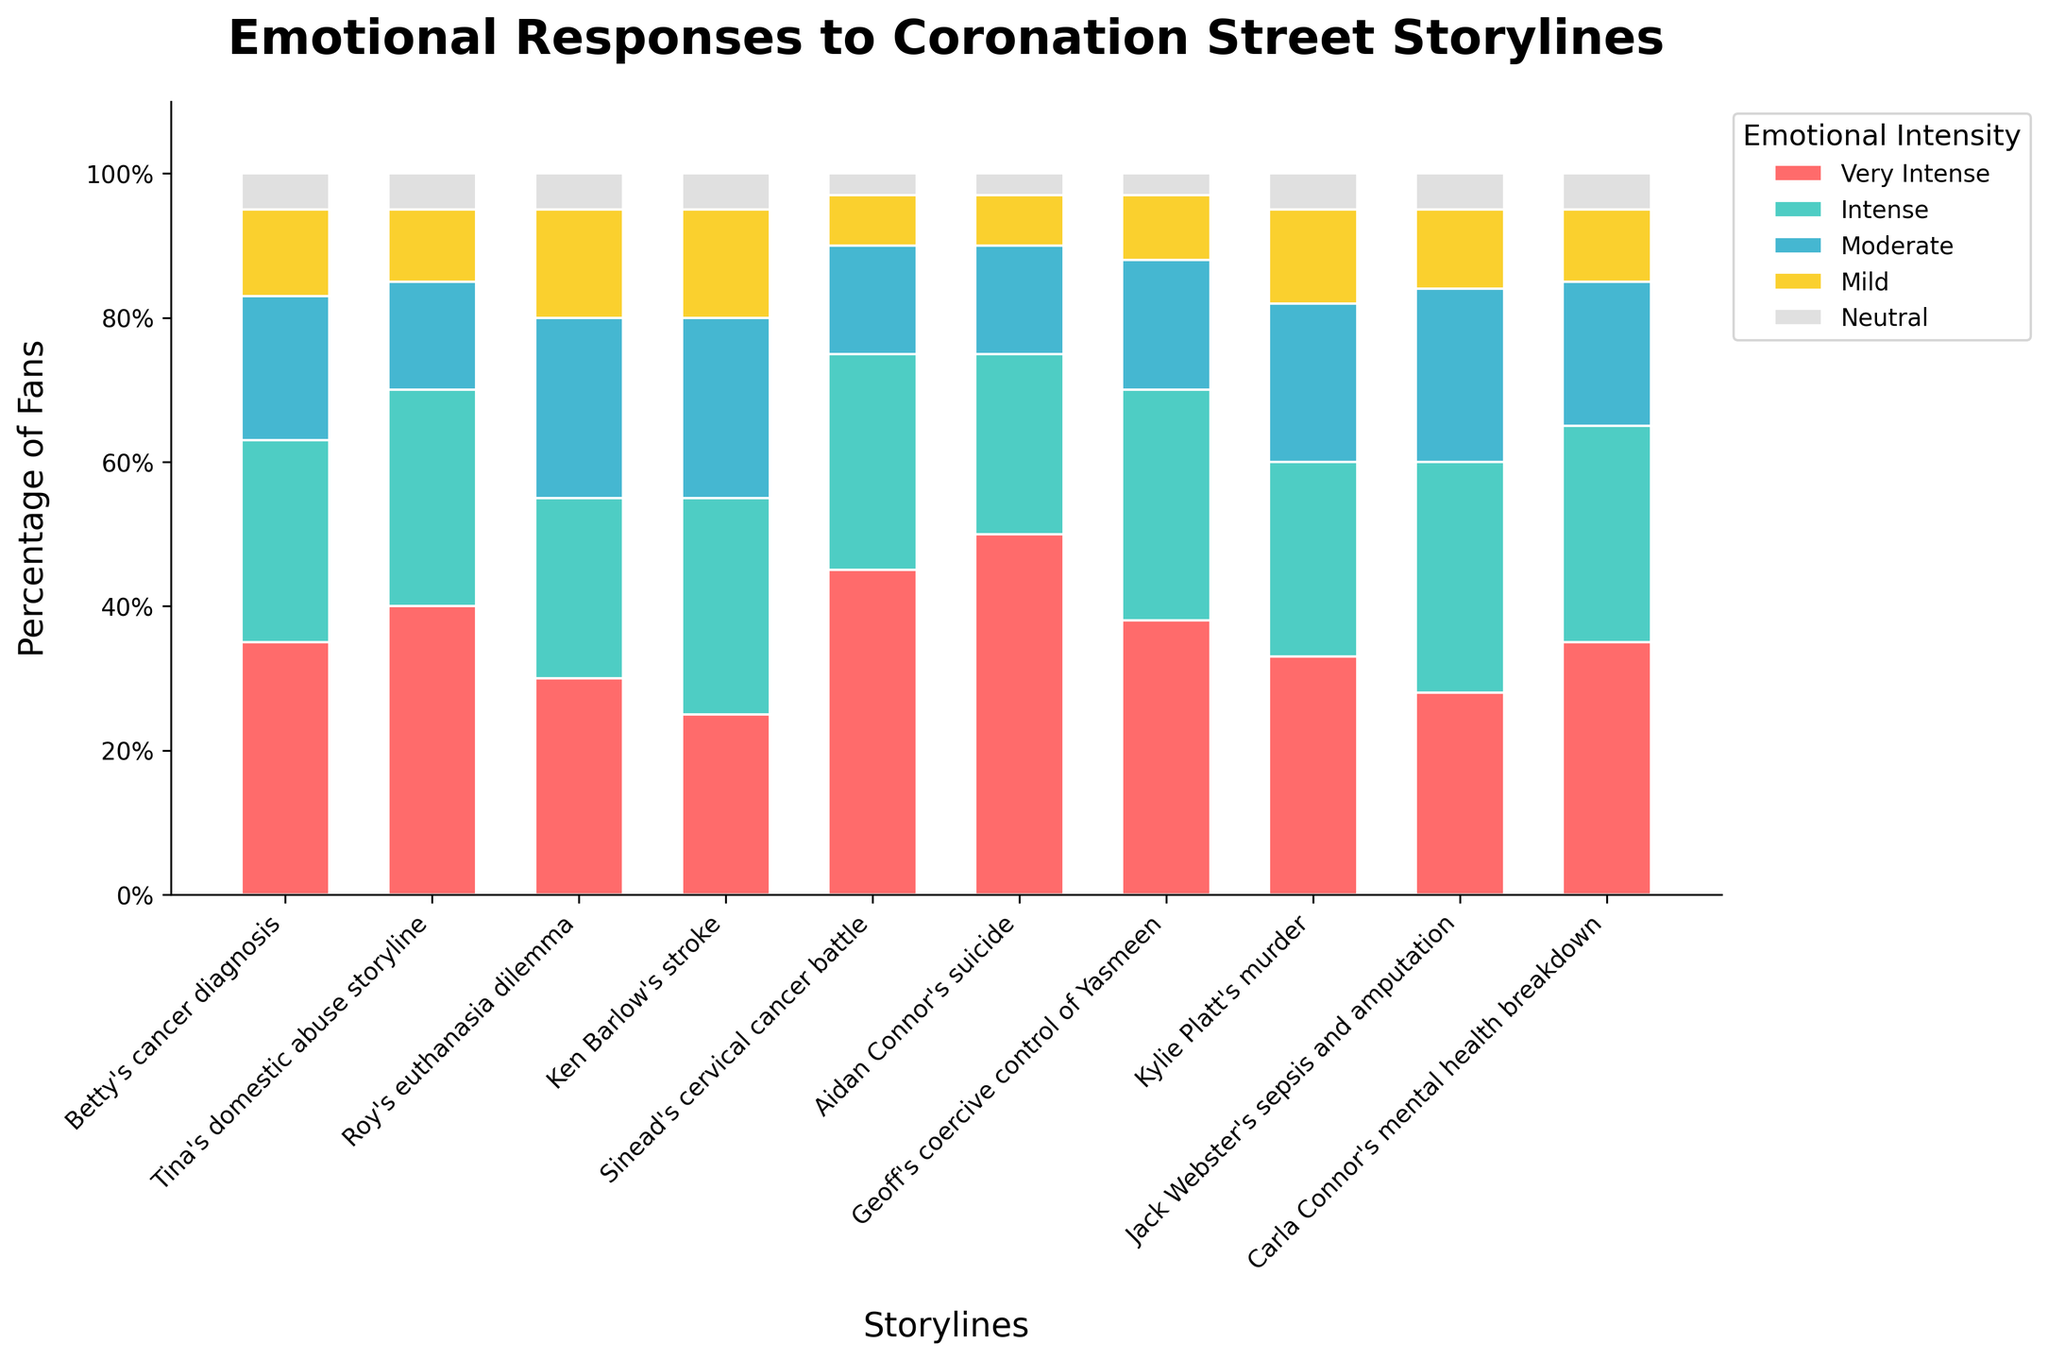What is the title of the figure? The title is usually found at the top of the chart, providing a brief summary of the data shown. Here, it clearly states the main subject of the figure, which is "Emotional Responses to Coronation Street Storylines".
Answer: Emotional Responses to Coronation Street Storylines How many categories of emotional intensity are displayed? Each distinct color in the chart's legend represents a category of emotional intensity. By counting these colors/categories, we find five: very intense, intense, moderate, mild, and neutral.
Answer: Five Which storyline had the highest percentage of fans with a 'very intense' emotional response? To determine this, we look for the category with the tallest bar segment in the 'very intense' color across all storylines. The storyline 'Aidan Connor's suicide' has the highest value for 'very intense' at 50%.
Answer: Aidan Connor's suicide Which emotional response category has the most consistent appearance across the storylines? By visually inspecting the length of each colored segment across all storylines, the 'neutral' category (light grey) appears most consistently, usually having the smallest and most similar sized segments.
Answer: Neutral How many storylines had exactly 30% of fans reporting 'intense' emotional responses? We identify the 'intense' bar segment (colored accordingly) and count the number of storylines where this segment reaches exactly 30. Four storylines fit this criterion: Tina's domestic abuse storyline, Ken Barlow's stroke, Sinead's cervical cancer battle, Carla Connor's mental health breakdown.
Answer: Four Which storyline had the least intense emotional responses overall? To determine which storyline evoked the least intense emotional reactions, we can focus on the 'very intense' category and find the lowest percentage value. 'Jack Webster's sepsis and amputation' had 28% very intense responses, the lowest among the listed storylines.
Answer: Jack Webster's sepsis and amputation What percentage of fans had a 'moderate' emotional response to Roy's euthanasia dilemma? To find this, we'll locate the 'moderate' bar segment (colored accordingly) for the 'Roy's euthanasia dilemma' storyline. The value is clearly marked on the chart: 25%.
Answer: 25% Aside from 'neutral', which storyline induced the least percentage of 'mild' emotional responses? Examine the 'mild' segment for each storyline and identify the lowest value besides the 'neutral' category. 'Sinead's cervical cancer battle' had 7% reporting mild responses, which is the lowest in this category.
Answer: Sinead's cervical cancer battle Which two storylines had an equal percentage of fans responding with 'very intense' emotions? Scan the 'very intense' bar segments across all storylines to see which ones have identical values. 'Roy's euthanasia dilemma' and 'Carla Connor's mental health breakdown' each have 35%.
Answer: Roy's euthanasia dilemma and Carla Connor's mental health breakdown What is the average 'intense' response percentage across all storylines? Sum the 'intense' percentages for each storyline (28, 30, 25, 30, 30, 25, 32, 27, 32, 30) to get 289, then divide by the number of storylines (10). 289 / 10 is 28.9%.
Answer: 28.9% 